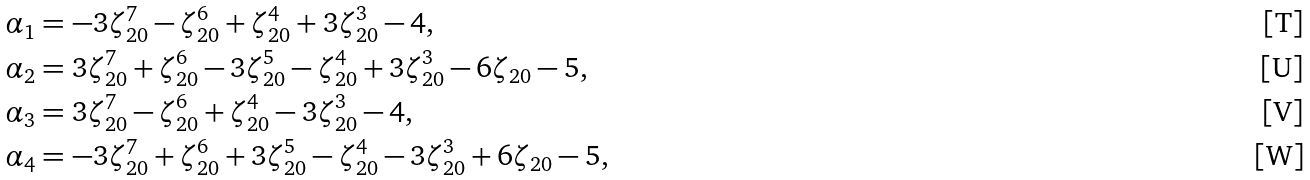Convert formula to latex. <formula><loc_0><loc_0><loc_500><loc_500>\alpha _ { 1 } & = - 3 \zeta _ { 2 0 } ^ { 7 } - \zeta _ { 2 0 } ^ { 6 } + \zeta _ { 2 0 } ^ { 4 } + 3 \zeta _ { 2 0 } ^ { 3 } - 4 , \\ \alpha _ { 2 } & = 3 \zeta _ { 2 0 } ^ { 7 } + \zeta _ { 2 0 } ^ { 6 } - 3 \zeta _ { 2 0 } ^ { 5 } - \zeta _ { 2 0 } ^ { 4 } + 3 \zeta _ { 2 0 } ^ { 3 } - 6 \zeta _ { 2 0 } - 5 , \\ \alpha _ { 3 } & = 3 \zeta _ { 2 0 } ^ { 7 } - \zeta _ { 2 0 } ^ { 6 } + \zeta _ { 2 0 } ^ { 4 } - 3 \zeta _ { 2 0 } ^ { 3 } - 4 , \\ \alpha _ { 4 } & = - 3 \zeta _ { 2 0 } ^ { 7 } + \zeta _ { 2 0 } ^ { 6 } + 3 \zeta _ { 2 0 } ^ { 5 } - \zeta _ { 2 0 } ^ { 4 } - 3 \zeta _ { 2 0 } ^ { 3 } + 6 \zeta _ { 2 0 } - 5 ,</formula> 